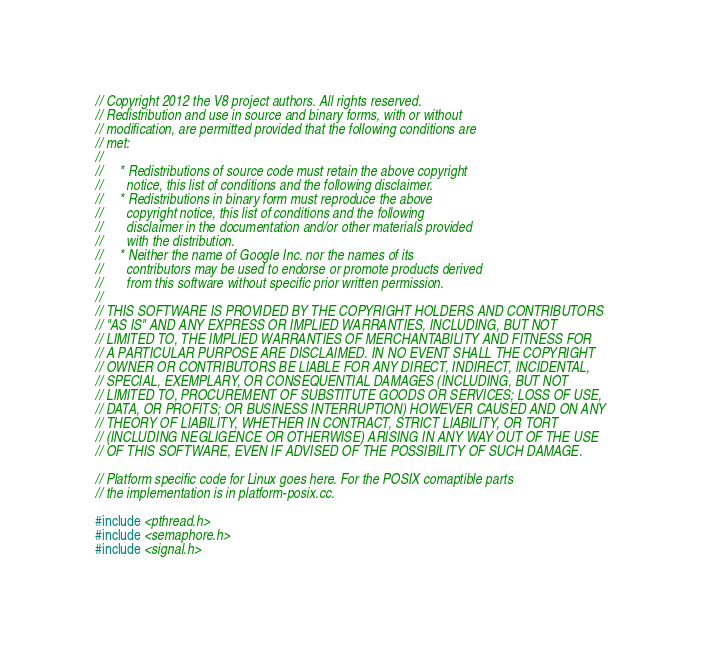Convert code to text. <code><loc_0><loc_0><loc_500><loc_500><_C++_>// Copyright 2012 the V8 project authors. All rights reserved.
// Redistribution and use in source and binary forms, with or without
// modification, are permitted provided that the following conditions are
// met:
//
//     * Redistributions of source code must retain the above copyright
//       notice, this list of conditions and the following disclaimer.
//     * Redistributions in binary form must reproduce the above
//       copyright notice, this list of conditions and the following
//       disclaimer in the documentation and/or other materials provided
//       with the distribution.
//     * Neither the name of Google Inc. nor the names of its
//       contributors may be used to endorse or promote products derived
//       from this software without specific prior written permission.
//
// THIS SOFTWARE IS PROVIDED BY THE COPYRIGHT HOLDERS AND CONTRIBUTORS
// "AS IS" AND ANY EXPRESS OR IMPLIED WARRANTIES, INCLUDING, BUT NOT
// LIMITED TO, THE IMPLIED WARRANTIES OF MERCHANTABILITY AND FITNESS FOR
// A PARTICULAR PURPOSE ARE DISCLAIMED. IN NO EVENT SHALL THE COPYRIGHT
// OWNER OR CONTRIBUTORS BE LIABLE FOR ANY DIRECT, INDIRECT, INCIDENTAL,
// SPECIAL, EXEMPLARY, OR CONSEQUENTIAL DAMAGES (INCLUDING, BUT NOT
// LIMITED TO, PROCUREMENT OF SUBSTITUTE GOODS OR SERVICES; LOSS OF USE,
// DATA, OR PROFITS; OR BUSINESS INTERRUPTION) HOWEVER CAUSED AND ON ANY
// THEORY OF LIABILITY, WHETHER IN CONTRACT, STRICT LIABILITY, OR TORT
// (INCLUDING NEGLIGENCE OR OTHERWISE) ARISING IN ANY WAY OUT OF THE USE
// OF THIS SOFTWARE, EVEN IF ADVISED OF THE POSSIBILITY OF SUCH DAMAGE.

// Platform specific code for Linux goes here. For the POSIX comaptible parts
// the implementation is in platform-posix.cc.

#include <pthread.h>
#include <semaphore.h>
#include <signal.h></code> 